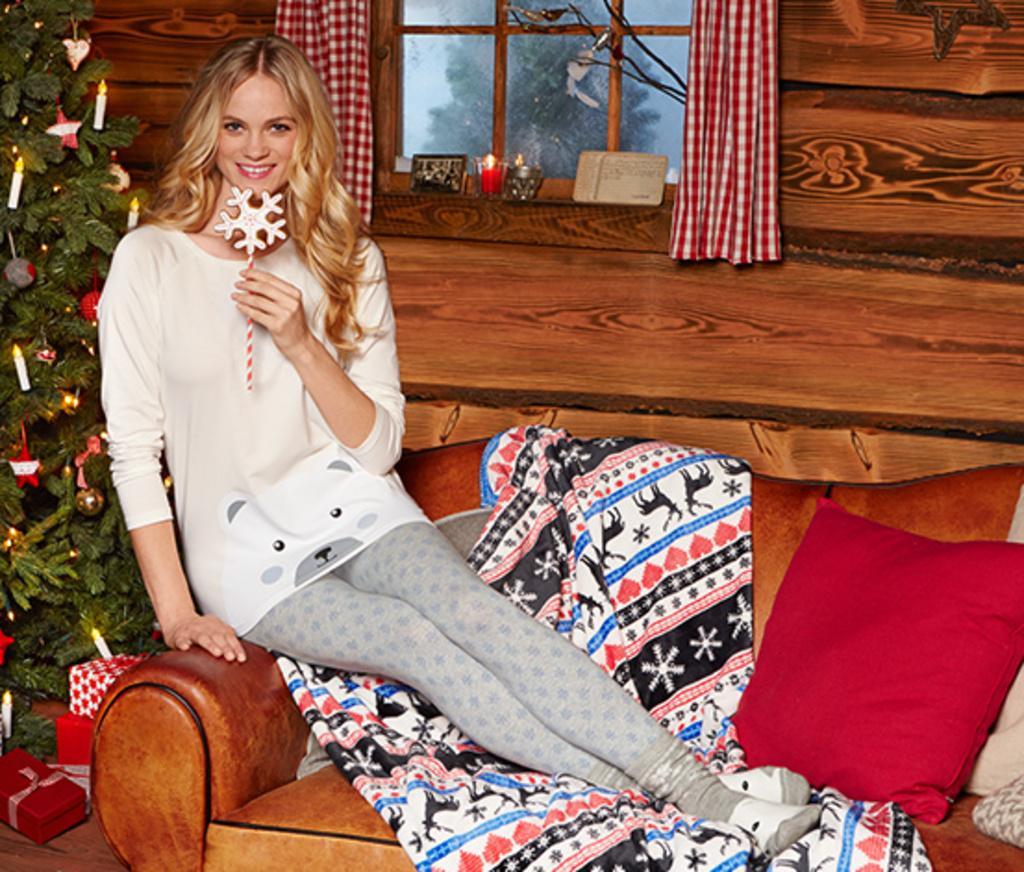Can you describe this image briefly? In this image I can see the person is on the couch and I can see the blanket, pillows on the couch. I can see the christmas tree, window, curtains, wall and few objects around. 